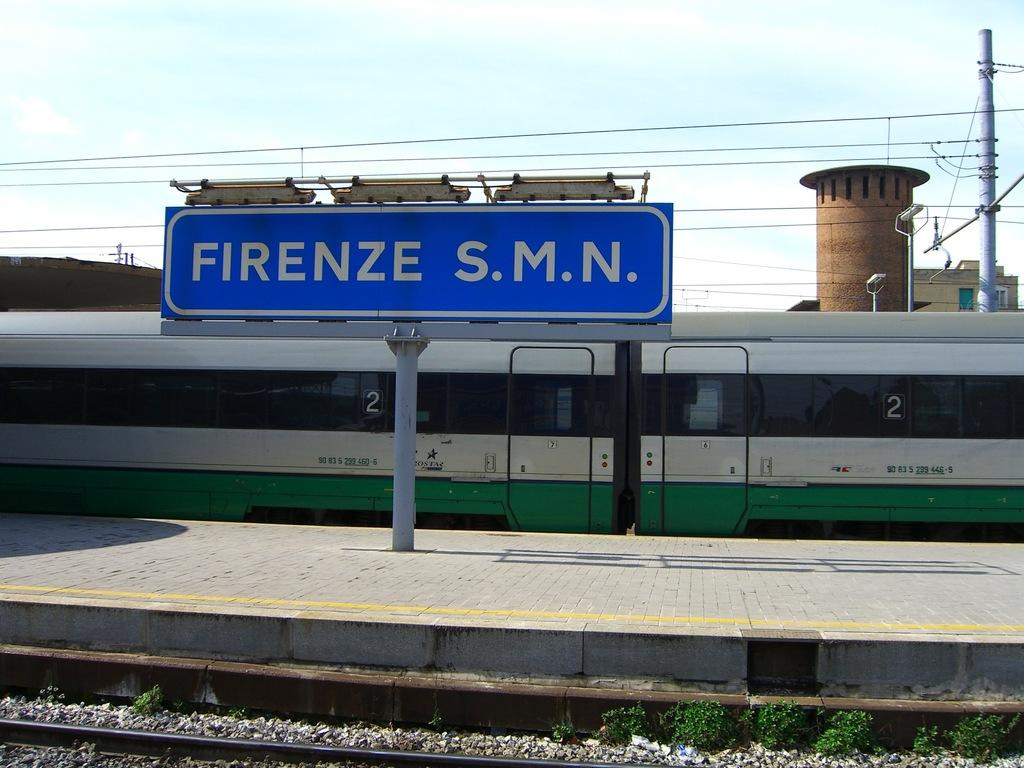<image>
Present a compact description of the photo's key features. a street sign in front of a subway with the number 2 on it that reads: Firenze s.m.n. 